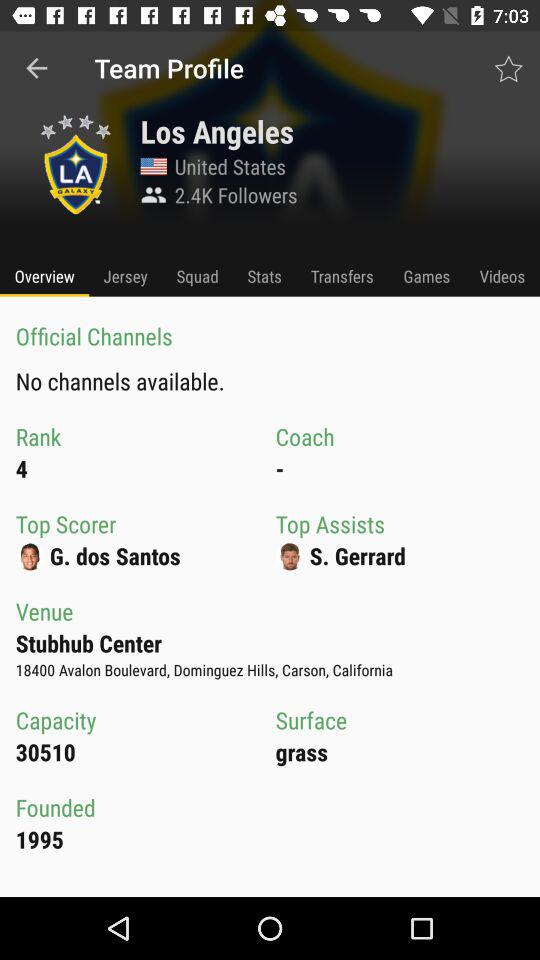Which tab is selected? The selected tab is "Overview". 